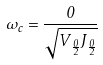Convert formula to latex. <formula><loc_0><loc_0><loc_500><loc_500>\omega _ { c } = \frac { 0 } { \sqrt { V _ { \frac { 0 } { 2 } } J _ { \frac { 0 } { 2 } } } }</formula> 